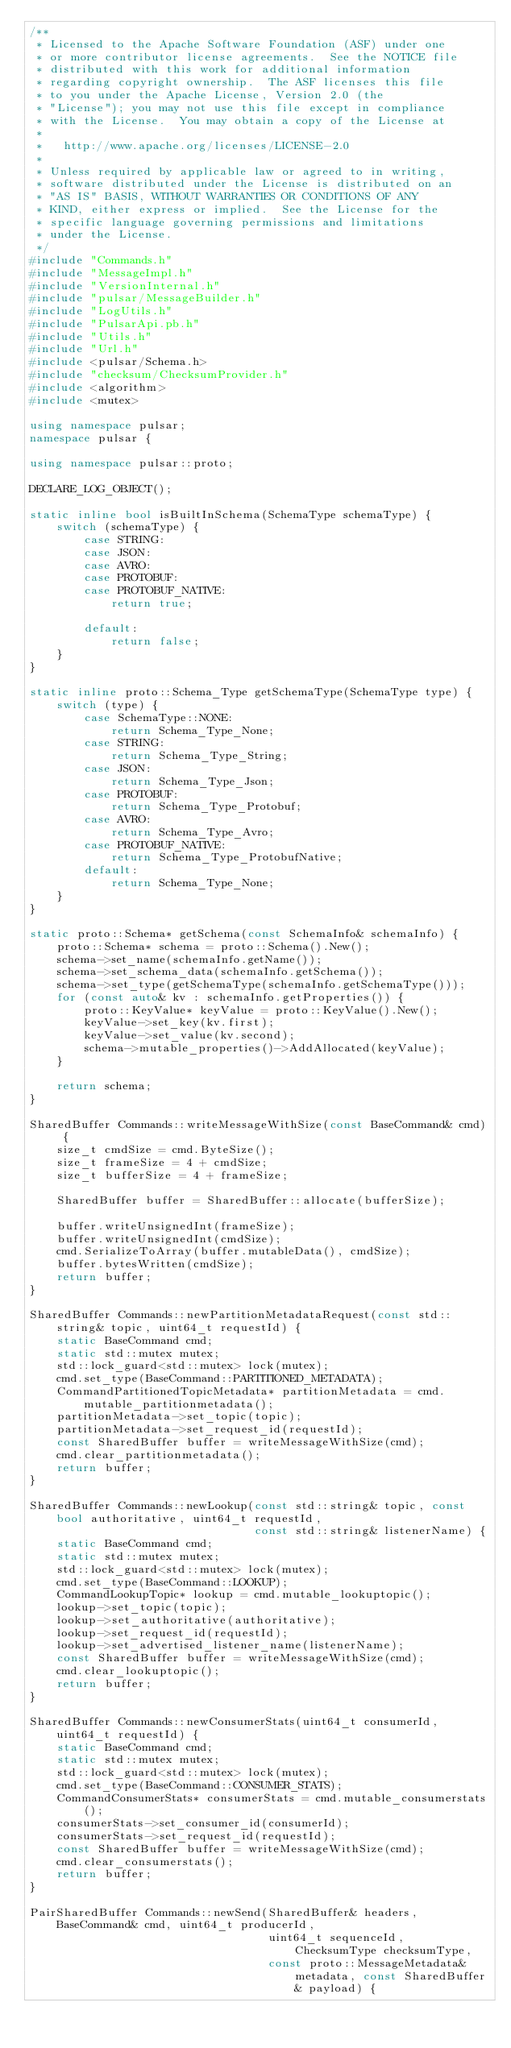Convert code to text. <code><loc_0><loc_0><loc_500><loc_500><_C++_>/**
 * Licensed to the Apache Software Foundation (ASF) under one
 * or more contributor license agreements.  See the NOTICE file
 * distributed with this work for additional information
 * regarding copyright ownership.  The ASF licenses this file
 * to you under the Apache License, Version 2.0 (the
 * "License"); you may not use this file except in compliance
 * with the License.  You may obtain a copy of the License at
 *
 *   http://www.apache.org/licenses/LICENSE-2.0
 *
 * Unless required by applicable law or agreed to in writing,
 * software distributed under the License is distributed on an
 * "AS IS" BASIS, WITHOUT WARRANTIES OR CONDITIONS OF ANY
 * KIND, either express or implied.  See the License for the
 * specific language governing permissions and limitations
 * under the License.
 */
#include "Commands.h"
#include "MessageImpl.h"
#include "VersionInternal.h"
#include "pulsar/MessageBuilder.h"
#include "LogUtils.h"
#include "PulsarApi.pb.h"
#include "Utils.h"
#include "Url.h"
#include <pulsar/Schema.h>
#include "checksum/ChecksumProvider.h"
#include <algorithm>
#include <mutex>

using namespace pulsar;
namespace pulsar {

using namespace pulsar::proto;

DECLARE_LOG_OBJECT();

static inline bool isBuiltInSchema(SchemaType schemaType) {
    switch (schemaType) {
        case STRING:
        case JSON:
        case AVRO:
        case PROTOBUF:
        case PROTOBUF_NATIVE:
            return true;

        default:
            return false;
    }
}

static inline proto::Schema_Type getSchemaType(SchemaType type) {
    switch (type) {
        case SchemaType::NONE:
            return Schema_Type_None;
        case STRING:
            return Schema_Type_String;
        case JSON:
            return Schema_Type_Json;
        case PROTOBUF:
            return Schema_Type_Protobuf;
        case AVRO:
            return Schema_Type_Avro;
        case PROTOBUF_NATIVE:
            return Schema_Type_ProtobufNative;
        default:
            return Schema_Type_None;
    }
}

static proto::Schema* getSchema(const SchemaInfo& schemaInfo) {
    proto::Schema* schema = proto::Schema().New();
    schema->set_name(schemaInfo.getName());
    schema->set_schema_data(schemaInfo.getSchema());
    schema->set_type(getSchemaType(schemaInfo.getSchemaType()));
    for (const auto& kv : schemaInfo.getProperties()) {
        proto::KeyValue* keyValue = proto::KeyValue().New();
        keyValue->set_key(kv.first);
        keyValue->set_value(kv.second);
        schema->mutable_properties()->AddAllocated(keyValue);
    }

    return schema;
}

SharedBuffer Commands::writeMessageWithSize(const BaseCommand& cmd) {
    size_t cmdSize = cmd.ByteSize();
    size_t frameSize = 4 + cmdSize;
    size_t bufferSize = 4 + frameSize;

    SharedBuffer buffer = SharedBuffer::allocate(bufferSize);

    buffer.writeUnsignedInt(frameSize);
    buffer.writeUnsignedInt(cmdSize);
    cmd.SerializeToArray(buffer.mutableData(), cmdSize);
    buffer.bytesWritten(cmdSize);
    return buffer;
}

SharedBuffer Commands::newPartitionMetadataRequest(const std::string& topic, uint64_t requestId) {
    static BaseCommand cmd;
    static std::mutex mutex;
    std::lock_guard<std::mutex> lock(mutex);
    cmd.set_type(BaseCommand::PARTITIONED_METADATA);
    CommandPartitionedTopicMetadata* partitionMetadata = cmd.mutable_partitionmetadata();
    partitionMetadata->set_topic(topic);
    partitionMetadata->set_request_id(requestId);
    const SharedBuffer buffer = writeMessageWithSize(cmd);
    cmd.clear_partitionmetadata();
    return buffer;
}

SharedBuffer Commands::newLookup(const std::string& topic, const bool authoritative, uint64_t requestId,
                                 const std::string& listenerName) {
    static BaseCommand cmd;
    static std::mutex mutex;
    std::lock_guard<std::mutex> lock(mutex);
    cmd.set_type(BaseCommand::LOOKUP);
    CommandLookupTopic* lookup = cmd.mutable_lookuptopic();
    lookup->set_topic(topic);
    lookup->set_authoritative(authoritative);
    lookup->set_request_id(requestId);
    lookup->set_advertised_listener_name(listenerName);
    const SharedBuffer buffer = writeMessageWithSize(cmd);
    cmd.clear_lookuptopic();
    return buffer;
}

SharedBuffer Commands::newConsumerStats(uint64_t consumerId, uint64_t requestId) {
    static BaseCommand cmd;
    static std::mutex mutex;
    std::lock_guard<std::mutex> lock(mutex);
    cmd.set_type(BaseCommand::CONSUMER_STATS);
    CommandConsumerStats* consumerStats = cmd.mutable_consumerstats();
    consumerStats->set_consumer_id(consumerId);
    consumerStats->set_request_id(requestId);
    const SharedBuffer buffer = writeMessageWithSize(cmd);
    cmd.clear_consumerstats();
    return buffer;
}

PairSharedBuffer Commands::newSend(SharedBuffer& headers, BaseCommand& cmd, uint64_t producerId,
                                   uint64_t sequenceId, ChecksumType checksumType,
                                   const proto::MessageMetadata& metadata, const SharedBuffer& payload) {</code> 